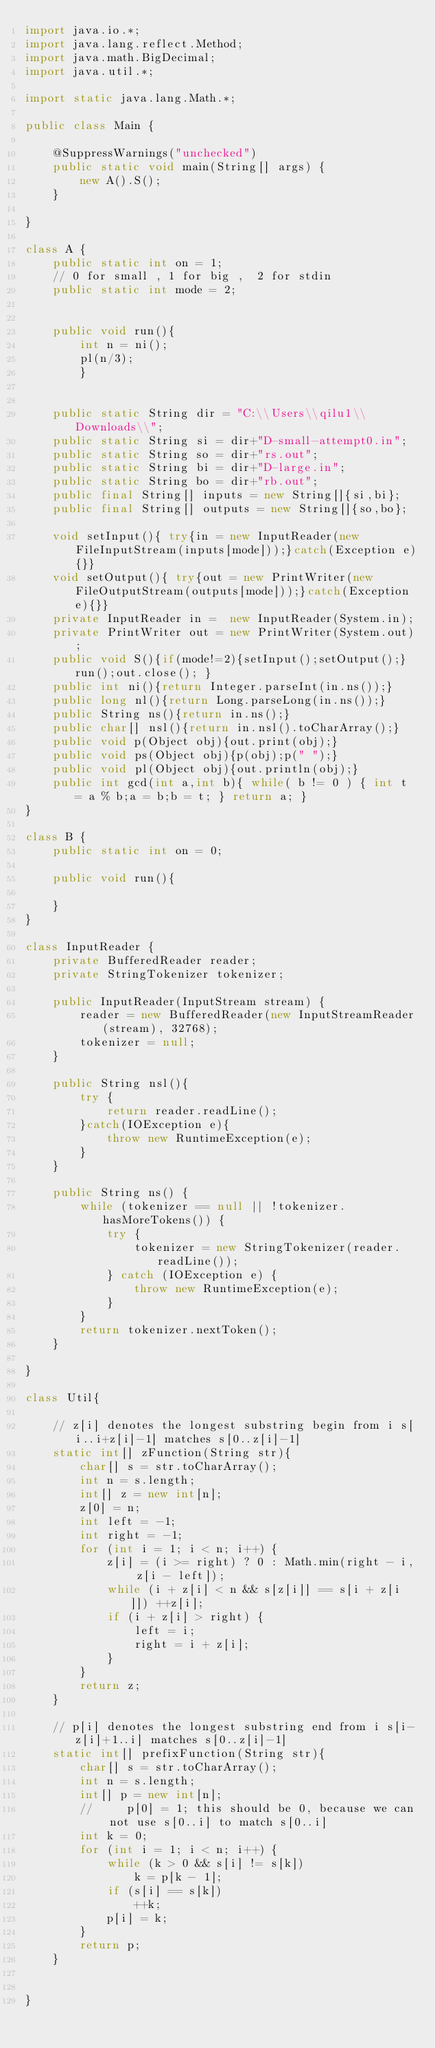<code> <loc_0><loc_0><loc_500><loc_500><_Java_>import java.io.*;
import java.lang.reflect.Method;
import java.math.BigDecimal;
import java.util.*;

import static java.lang.Math.*;

public class Main {

    @SuppressWarnings("unchecked")
    public static void main(String[] args) {
        new A().S();
    }

}

class A {
    public static int on = 1;
    // 0 for small , 1 for big ,  2 for stdin
    public static int mode = 2;


    public void run(){
        int n = ni();
        pl(n/3);
        }


    public static String dir = "C:\\Users\\qilu1\\Downloads\\";
    public static String si = dir+"D-small-attempt0.in";
    public static String so = dir+"rs.out";
    public static String bi = dir+"D-large.in";
    public static String bo = dir+"rb.out";
    public final String[] inputs = new String[]{si,bi};
    public final String[] outputs = new String[]{so,bo};

    void setInput(){ try{in = new InputReader(new FileInputStream(inputs[mode]));}catch(Exception e){}}
    void setOutput(){ try{out = new PrintWriter(new FileOutputStream(outputs[mode]));}catch(Exception e){}}
    private InputReader in =  new InputReader(System.in);
    private PrintWriter out = new PrintWriter(System.out);
    public void S(){if(mode!=2){setInput();setOutput();}run();out.close(); }
    public int ni(){return Integer.parseInt(in.ns());}
    public long nl(){return Long.parseLong(in.ns());}
    public String ns(){return in.ns();}
    public char[] nsl(){return in.nsl().toCharArray();}
    public void p(Object obj){out.print(obj);}
    public void ps(Object obj){p(obj);p(" ");}
    public void pl(Object obj){out.println(obj);}
    public int gcd(int a,int b){ while( b != 0 ) { int t = a % b;a = b;b = t; } return a; }
}

class B {
    public static int on = 0;

    public void run(){

    }
}

class InputReader {
    private BufferedReader reader;
    private StringTokenizer tokenizer;

    public InputReader(InputStream stream) {
        reader = new BufferedReader(new InputStreamReader(stream), 32768);
        tokenizer = null;
    }

    public String nsl(){
        try {
            return reader.readLine();
        }catch(IOException e){
            throw new RuntimeException(e);
        }
    }

    public String ns() {
        while (tokenizer == null || !tokenizer.hasMoreTokens()) {
            try {
                tokenizer = new StringTokenizer(reader.readLine());
            } catch (IOException e) {
                throw new RuntimeException(e);
            }
        }
        return tokenizer.nextToken();
    }

}

class Util{

    // z[i] denotes the longest substring begin from i s[i..i+z[i]-1] matches s[0..z[i]-1]
    static int[] zFunction(String str){
        char[] s = str.toCharArray();
        int n = s.length;
        int[] z = new int[n];
        z[0] = n;
        int left = -1;
        int right = -1;
        for (int i = 1; i < n; i++) {
            z[i] = (i >= right) ? 0 : Math.min(right - i, z[i - left]);
            while (i + z[i] < n && s[z[i]] == s[i + z[i]]) ++z[i];
            if (i + z[i] > right) {
                left = i;
                right = i + z[i];
            }
        }
        return z;
    }

    // p[i] denotes the longest substring end from i s[i-z[i]+1..i] matches s[0..z[i]-1]
    static int[] prefixFunction(String str){
        char[] s = str.toCharArray();
        int n = s.length;
        int[] p = new int[n];
        //     p[0] = 1; this should be 0, because we can not use s[0..i] to match s[0..i]
        int k = 0;
        for (int i = 1; i < n; i++) {
            while (k > 0 && s[i] != s[k])
                k = p[k - 1];
            if (s[i] == s[k])
                ++k;
            p[i] = k;
        }
        return p;
    }


}</code> 